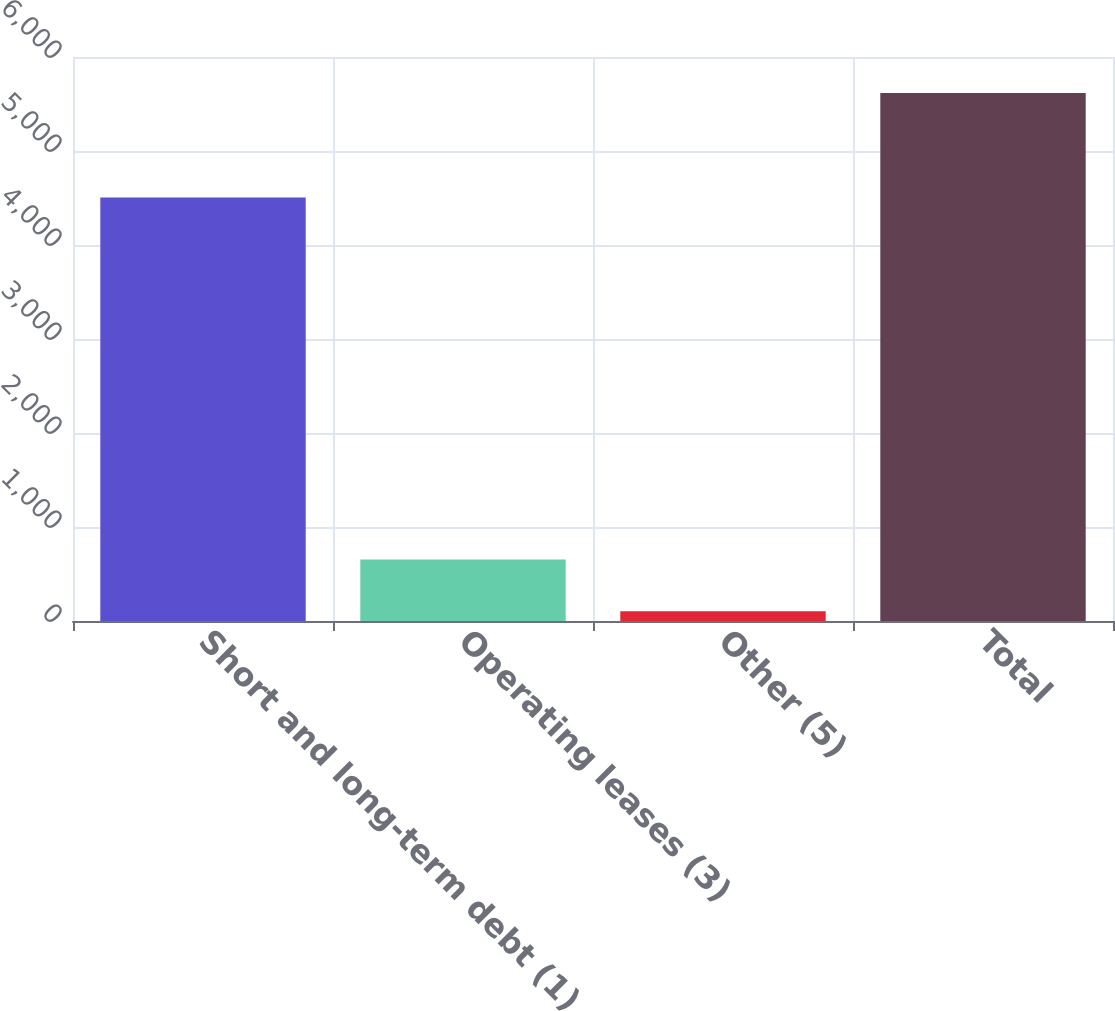Convert chart to OTSL. <chart><loc_0><loc_0><loc_500><loc_500><bar_chart><fcel>Short and long-term debt (1)<fcel>Operating leases (3)<fcel>Other (5)<fcel>Total<nl><fcel>4504.9<fcel>654.34<fcel>103<fcel>5616.4<nl></chart> 